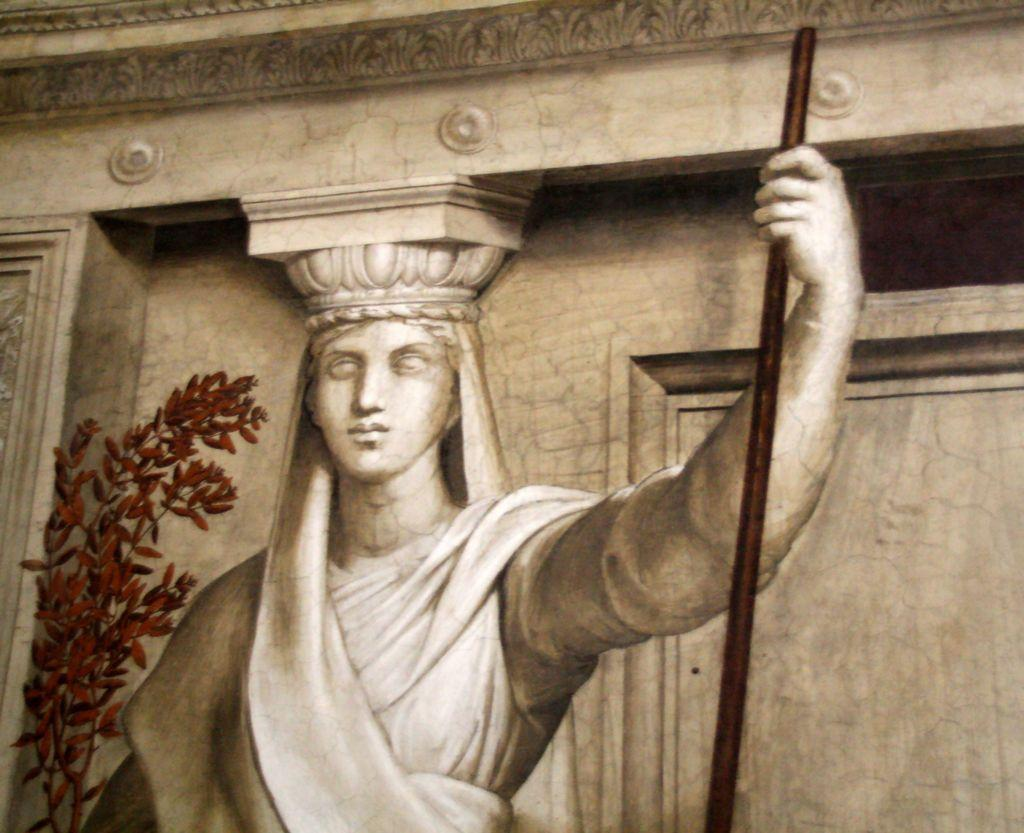What is the main subject of the image? There is a sculpture of a woman in the image. What is the woman holding in the image? The woman is holding a stick. What can be seen behind the woman in the image? There is a tree behind the woman. What is the color of the tree in the image? The tree is brown in color. What is visible in the background of the image? There is a wall in the background of the image. What type of treatment is the giraffe receiving in the image? There is no giraffe present in the image, and therefore no treatment can be observed. 